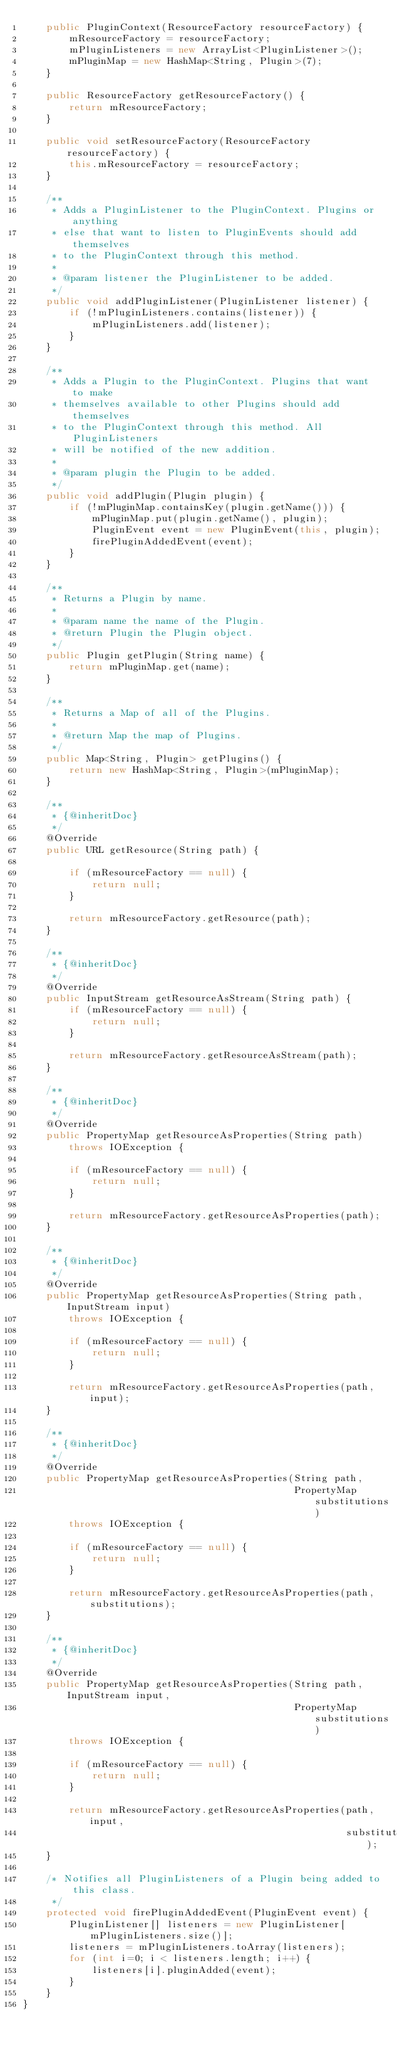Convert code to text. <code><loc_0><loc_0><loc_500><loc_500><_Java_>    public PluginContext(ResourceFactory resourceFactory) {
        mResourceFactory = resourceFactory;
        mPluginListeners = new ArrayList<PluginListener>();
        mPluginMap = new HashMap<String, Plugin>(7);
    }
    
    public ResourceFactory getResourceFactory() {
        return mResourceFactory;
    }
    
    public void setResourceFactory(ResourceFactory resourceFactory) {
        this.mResourceFactory = resourceFactory;
    }
   
    /**
     * Adds a PluginListener to the PluginContext. Plugins or anything
     * else that want to listen to PluginEvents should add themselves
     * to the PluginContext through this method.
     *
     * @param listener the PluginListener to be added.
     */
    public void addPluginListener(PluginListener listener) {
        if (!mPluginListeners.contains(listener)) {
            mPluginListeners.add(listener);
        }
    }
    
    /**
     * Adds a Plugin to the PluginContext. Plugins that want to make
     * themselves available to other Plugins should add themselves
     * to the PluginContext through this method. All PluginListeners
     * will be notified of the new addition.
     *
     * @param plugin the Plugin to be added.
     */
    public void addPlugin(Plugin plugin) {
        if (!mPluginMap.containsKey(plugin.getName())) {
            mPluginMap.put(plugin.getName(), plugin);
            PluginEvent event = new PluginEvent(this, plugin);
            firePluginAddedEvent(event);
        }
    }

    /**
     * Returns a Plugin by name.
     *
     * @param name the name of the Plugin.
     * @return Plugin the Plugin object.
     */
    public Plugin getPlugin(String name) {
        return mPluginMap.get(name);
    }
    
    /**
     * Returns a Map of all of the Plugins.
     *
     * @return Map the map of Plugins.
     */
    public Map<String, Plugin> getPlugins() {
        return new HashMap<String, Plugin>(mPluginMap);		
    }	
    
    /**
     * {@inheritDoc}
     */
    @Override
    public URL getResource(String path) {
        
        if (mResourceFactory == null) {
            return null;
        }
        
        return mResourceFactory.getResource(path);
    }

    /**
     * {@inheritDoc}
     */
    @Override
    public InputStream getResourceAsStream(String path) {
        if (mResourceFactory == null) {
            return null;
        }
        
        return mResourceFactory.getResourceAsStream(path);
    }
    
    /**
     * {@inheritDoc}
     */
    @Override
    public PropertyMap getResourceAsProperties(String path) 
        throws IOException {
        
        if (mResourceFactory == null) {
            return null;
        }
        
        return mResourceFactory.getResourceAsProperties(path);
    }
    
    /**
     * {@inheritDoc}
     */
    @Override
    public PropertyMap getResourceAsProperties(String path, InputStream input) 
        throws IOException {
        
        if (mResourceFactory == null) {
            return null;
        }
        
        return mResourceFactory.getResourceAsProperties(path, input);
    }
    
    /**
     * {@inheritDoc}
     */
    @Override
    public PropertyMap getResourceAsProperties(String path, 
                                               PropertyMap substitutions)
        throws IOException {
        
        if (mResourceFactory == null) {
            return null;
        }
        
        return mResourceFactory.getResourceAsProperties(path, substitutions);
    }
    
    /**
     * {@inheritDoc}
     */
    @Override
    public PropertyMap getResourceAsProperties(String path, InputStream input,
                                               PropertyMap substitutions)
        throws IOException {
        
        if (mResourceFactory == null) {
            return null;
        }
        
        return mResourceFactory.getResourceAsProperties(path, input,
                                                        substitutions);
    }
    
    /* Notifies all PluginListeners of a Plugin being added to this class.
     */
    protected void firePluginAddedEvent(PluginEvent event) {
        PluginListener[] listeners = new PluginListener[mPluginListeners.size()];
        listeners = mPluginListeners.toArray(listeners);
        for (int i=0; i < listeners.length; i++) {			
            listeners[i].pluginAdded(event);
        }
    }
}
</code> 